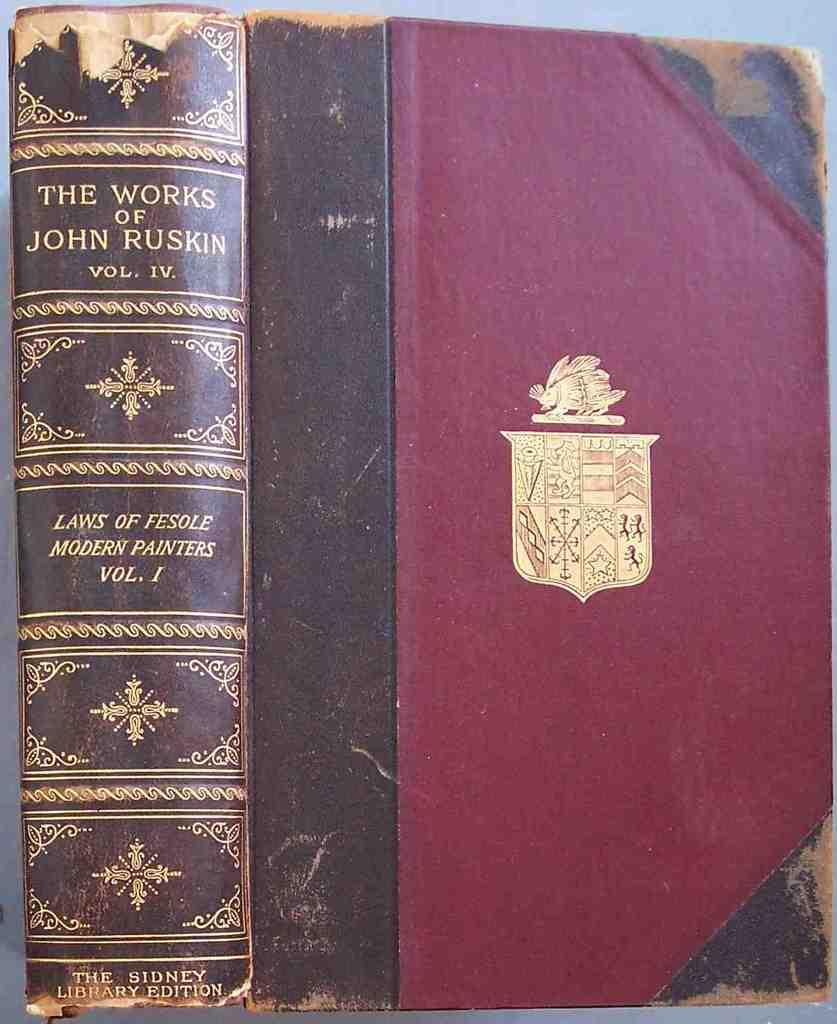<image>
Offer a succinct explanation of the picture presented. The ornate spine of a book identifies the book's title as Laws of Fesole Modern Painters. 